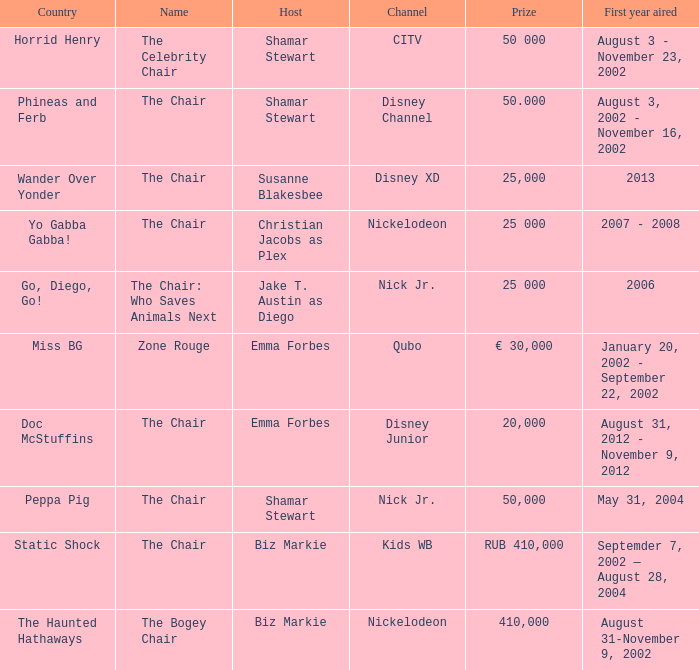What was the premiere year of zone rouge? January 20, 2002 - September 22, 2002. Can you give me this table as a dict? {'header': ['Country', 'Name', 'Host', 'Channel', 'Prize', 'First year aired'], 'rows': [['Horrid Henry', 'The Celebrity Chair', 'Shamar Stewart', 'CITV', '50 000', 'August 3 - November 23, 2002'], ['Phineas and Ferb', 'The Chair', 'Shamar Stewart', 'Disney Channel', '50.000', 'August 3, 2002 - November 16, 2002'], ['Wander Over Yonder', 'The Chair', 'Susanne Blakesbee', 'Disney XD', '25,000', '2013'], ['Yo Gabba Gabba!', 'The Chair', 'Christian Jacobs as Plex', 'Nickelodeon', '25 000', '2007 - 2008'], ['Go, Diego, Go!', 'The Chair: Who Saves Animals Next', 'Jake T. Austin as Diego', 'Nick Jr.', '25 000', '2006'], ['Miss BG', 'Zone Rouge', 'Emma Forbes', 'Qubo', '€ 30,000', 'January 20, 2002 - September 22, 2002'], ['Doc McStuffins', 'The Chair', 'Emma Forbes', 'Disney Junior', '20,000', 'August 31, 2012 - November 9, 2012'], ['Peppa Pig', 'The Chair', 'Shamar Stewart', 'Nick Jr.', '50,000', 'May 31, 2004'], ['Static Shock', 'The Chair', 'Biz Markie', 'Kids WB', 'RUB 410,000', 'Septemder 7, 2002 — August 28, 2004'], ['The Haunted Hathaways', 'The Bogey Chair', 'Biz Markie', 'Nickelodeon', '410,000', 'August 31-November 9, 2002']]} 